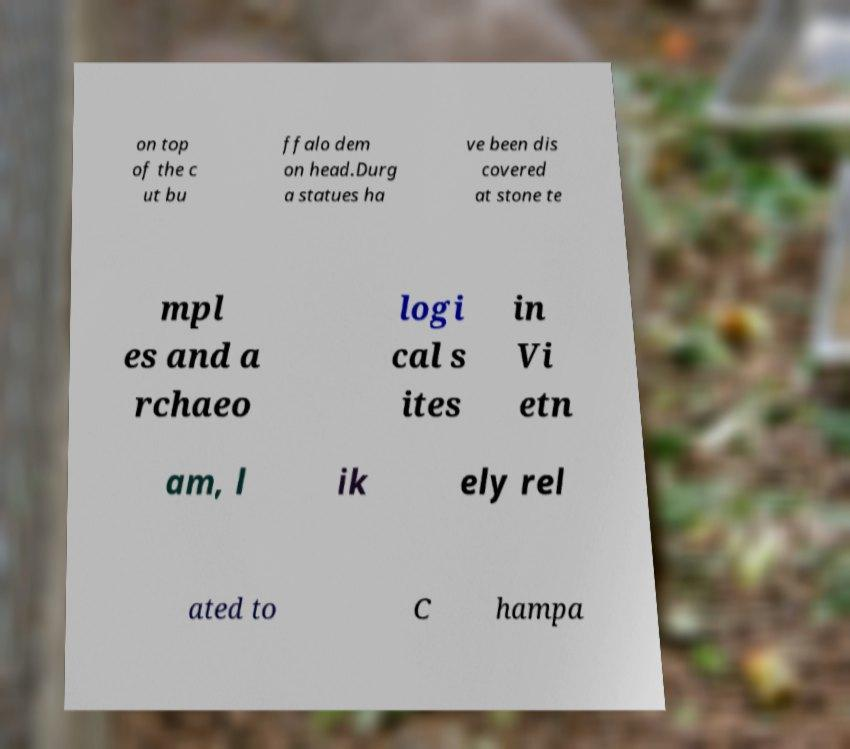Could you extract and type out the text from this image? on top of the c ut bu ffalo dem on head.Durg a statues ha ve been dis covered at stone te mpl es and a rchaeo logi cal s ites in Vi etn am, l ik ely rel ated to C hampa 